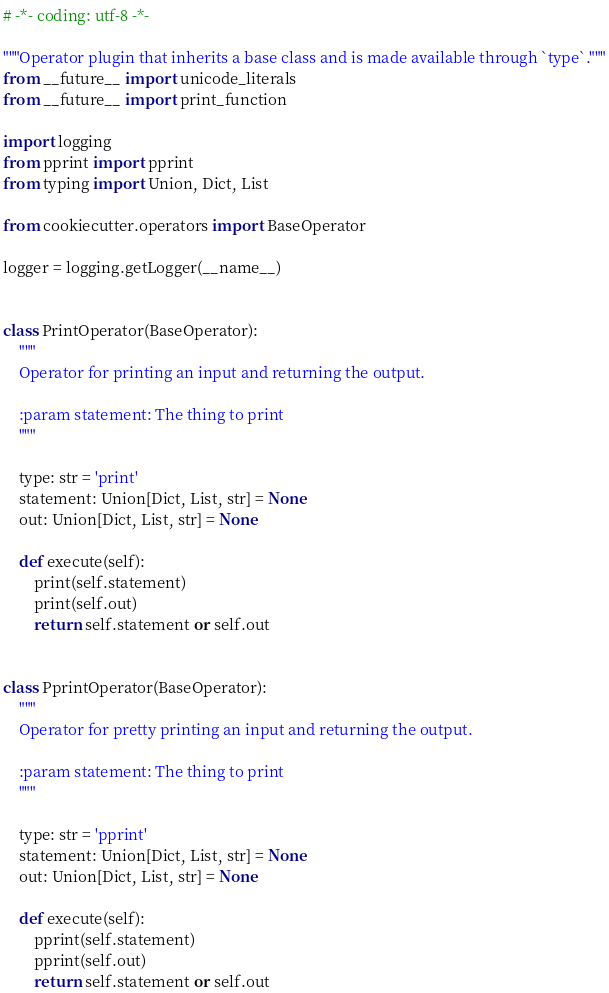Convert code to text. <code><loc_0><loc_0><loc_500><loc_500><_Python_># -*- coding: utf-8 -*-

"""Operator plugin that inherits a base class and is made available through `type`."""
from __future__ import unicode_literals
from __future__ import print_function

import logging
from pprint import pprint
from typing import Union, Dict, List

from cookiecutter.operators import BaseOperator

logger = logging.getLogger(__name__)


class PrintOperator(BaseOperator):
    """
    Operator for printing an input and returning the output.

    :param statement: The thing to print
    """

    type: str = 'print'
    statement: Union[Dict, List, str] = None
    out: Union[Dict, List, str] = None

    def execute(self):
        print(self.statement)
        print(self.out)
        return self.statement or self.out


class PprintOperator(BaseOperator):
    """
    Operator for pretty printing an input and returning the output.

    :param statement: The thing to print
    """

    type: str = 'pprint'
    statement: Union[Dict, List, str] = None
    out: Union[Dict, List, str] = None

    def execute(self):
        pprint(self.statement)
        pprint(self.out)
        return self.statement or self.out
</code> 